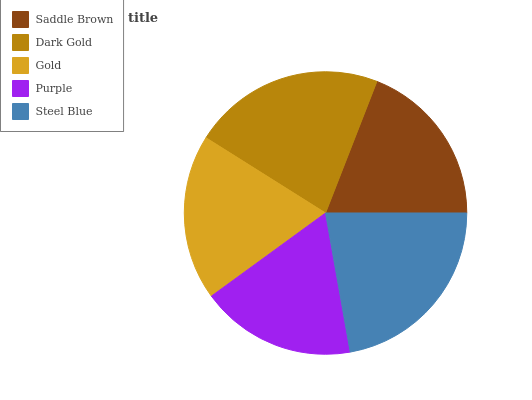Is Purple the minimum?
Answer yes or no. Yes. Is Steel Blue the maximum?
Answer yes or no. Yes. Is Dark Gold the minimum?
Answer yes or no. No. Is Dark Gold the maximum?
Answer yes or no. No. Is Dark Gold greater than Saddle Brown?
Answer yes or no. Yes. Is Saddle Brown less than Dark Gold?
Answer yes or no. Yes. Is Saddle Brown greater than Dark Gold?
Answer yes or no. No. Is Dark Gold less than Saddle Brown?
Answer yes or no. No. Is Saddle Brown the high median?
Answer yes or no. Yes. Is Saddle Brown the low median?
Answer yes or no. Yes. Is Dark Gold the high median?
Answer yes or no. No. Is Steel Blue the low median?
Answer yes or no. No. 